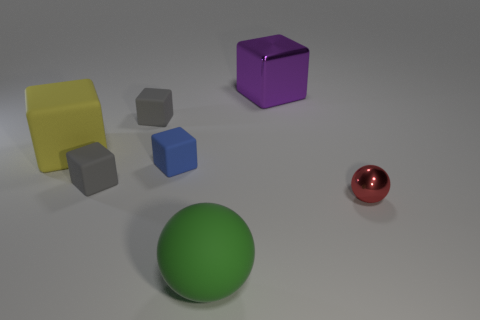Can you describe the lighting and shadows visible in this image? The lighting in the image appears to be soft and diffused, coming from the upper left. This creates gentle shadows that extend to the right of each object, indicating that the light source is not overly harsh and provides a natural ambiance to the scene. 